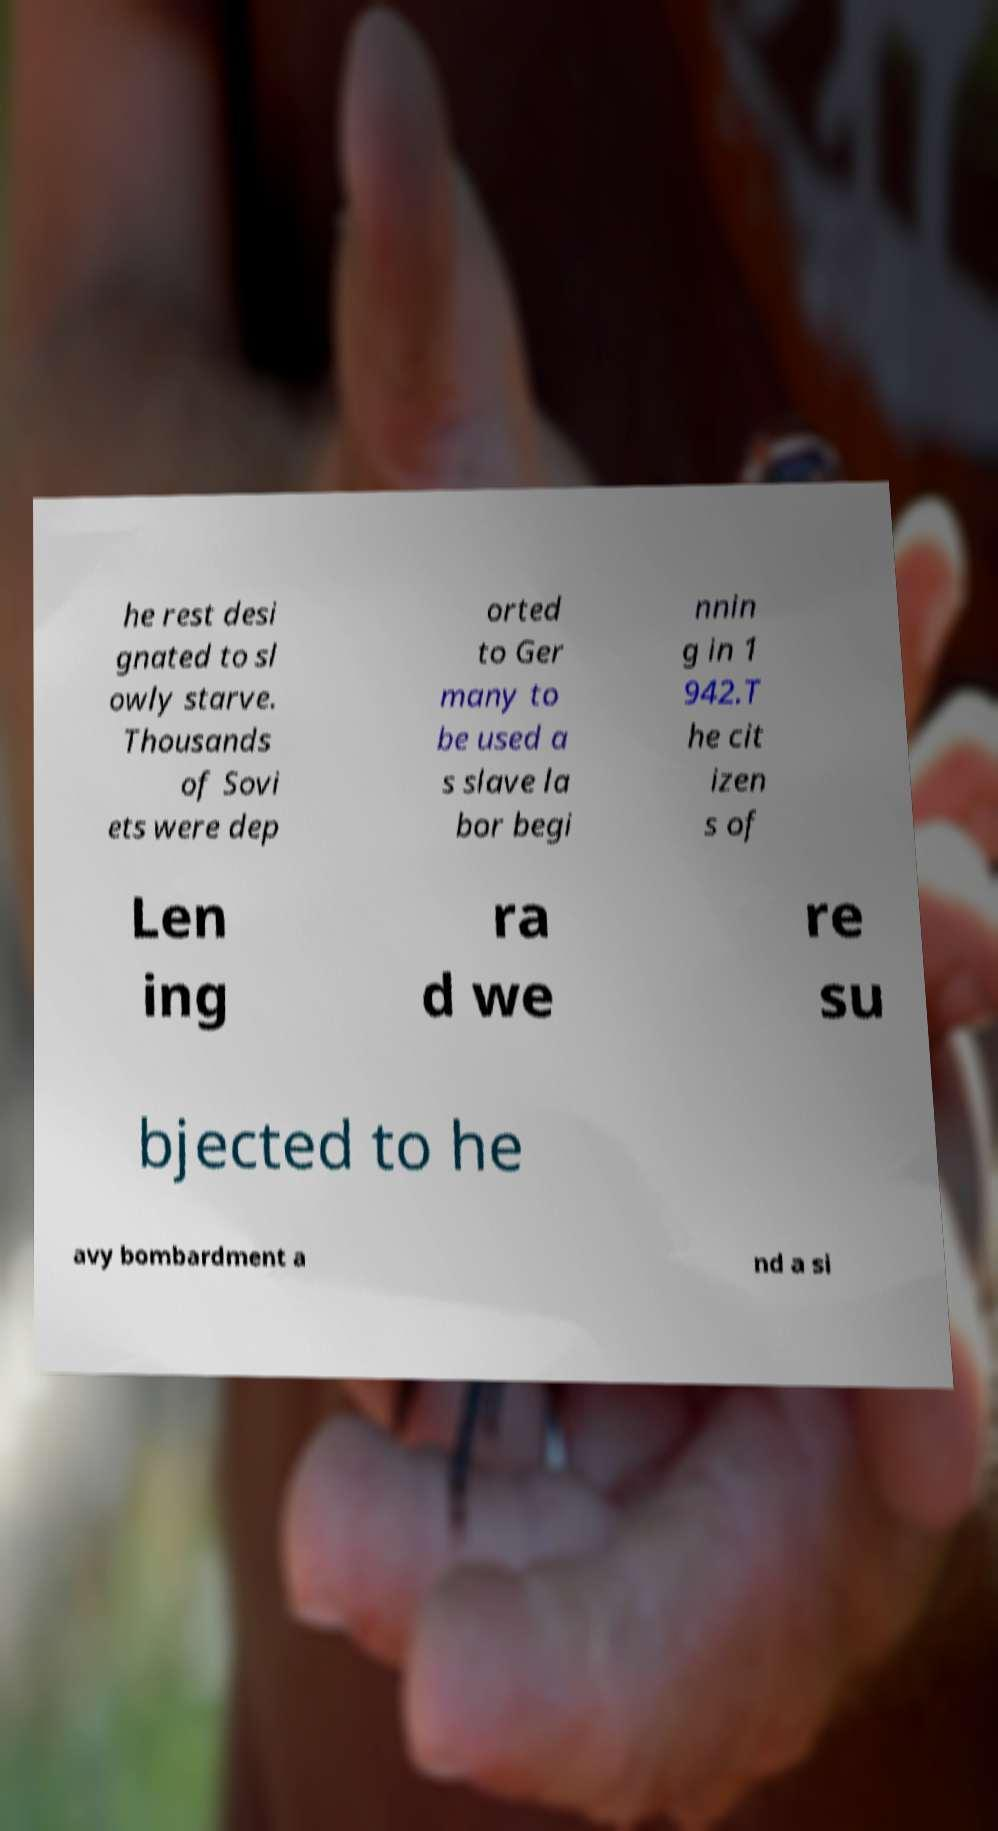Could you assist in decoding the text presented in this image and type it out clearly? he rest desi gnated to sl owly starve. Thousands of Sovi ets were dep orted to Ger many to be used a s slave la bor begi nnin g in 1 942.T he cit izen s of Len ing ra d we re su bjected to he avy bombardment a nd a si 